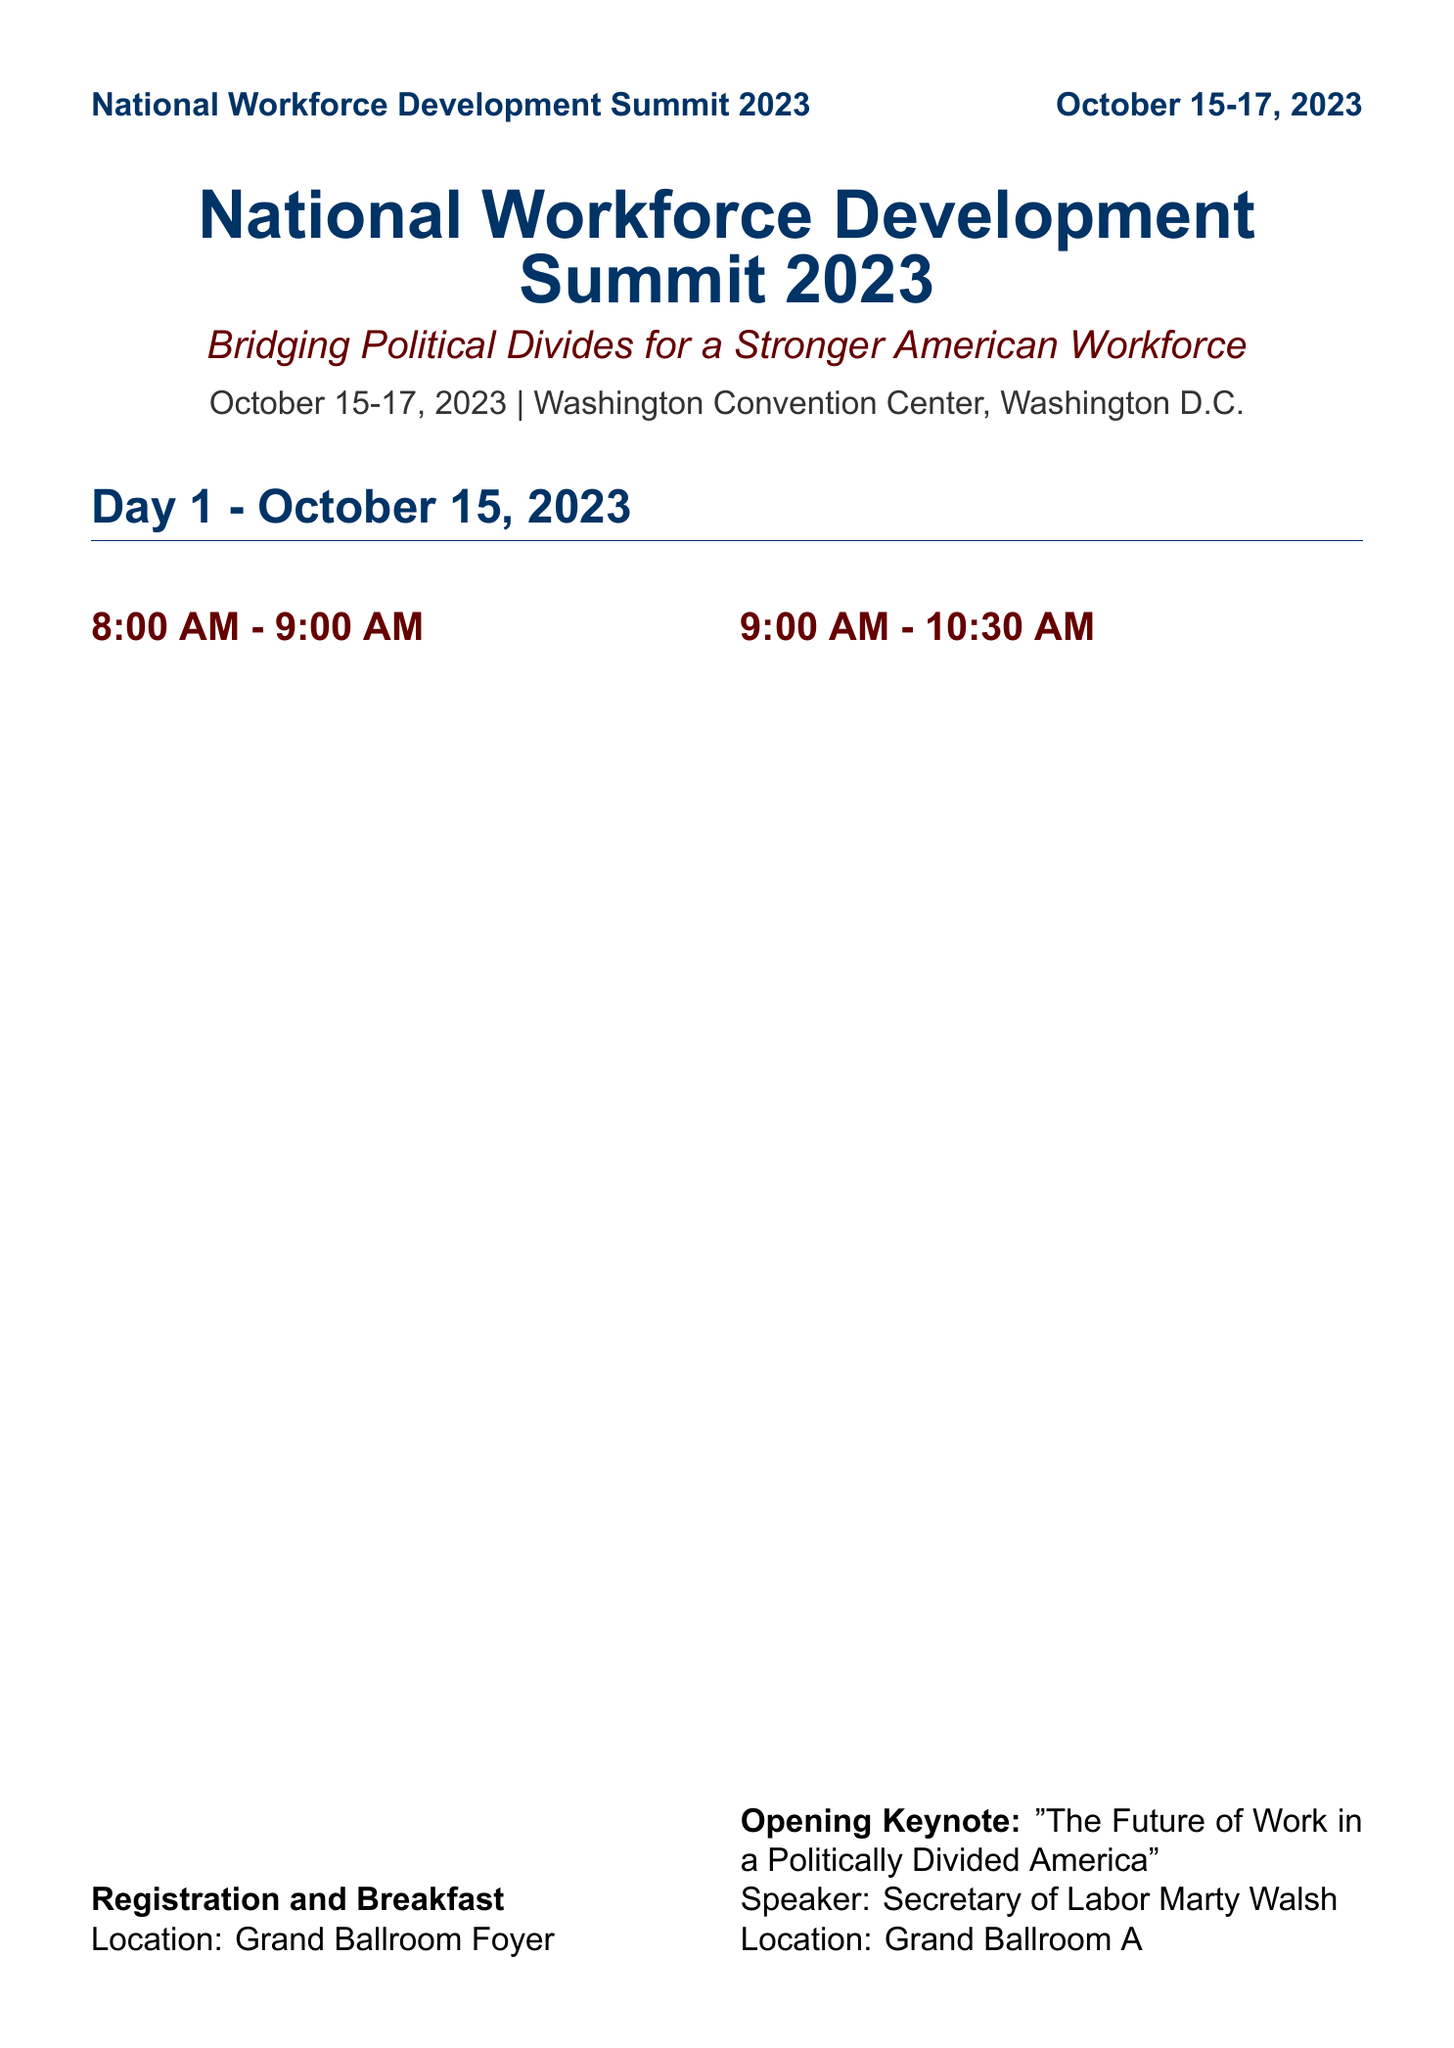What are the dates of the National Workforce Development Summit 2023? The document specifies the dates for the conference in its header.
Answer: October 15-17, 2023 Who is the speaker for the opening keynote? The opening keynote section mentions the speaker for that event.
Answer: Secretary of Labor Marty Walsh What is the location of the Welcome Reception? The document specifies different locations for various events, including the Welcome Reception.
Answer: Rooftop Terrace Which panel discussion is moderated by Arne Duncan? The document lists panel discussions and their moderators, allowing identification of the correct one.
Answer: Education Reform: Aligning Skills with Market Demands How long is the Closing Keynote session? The duration of the Closing Keynote can be inferred from the start and end times in the document.
Answer: 1 hour 30 minutes Which two governors are speaking at the Closing Keynote? The document lists speakers for the Closing Keynote, allowing identification of the individuals.
Answer: Governor Gretchen Whitmer, Governor Glenn Youngkin How many breakout sessions are there on Day 2? The document enumerates the breakout sessions on Day 2, which can be directly counted.
Answer: 3 What is the theme of the conference? The document clearly states the theme at the top.
Answer: Bridging Political Divides for a Stronger American Workforce Who are the moderators for the Town Hall session? The Town Hall section lists its moderators, allowing easy identification.
Answer: Jake Tapper, Bret Baier 